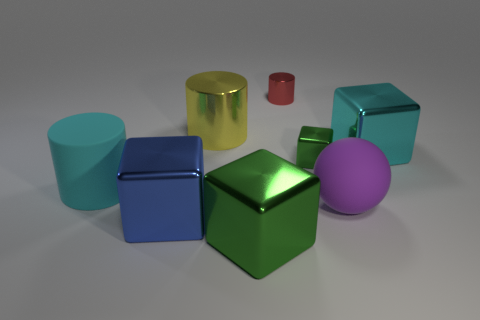What is the size of the metallic cube that is the same color as the rubber cylinder?
Your answer should be very brief. Large. What number of spheres are the same size as the red cylinder?
Your response must be concise. 0. Is the number of tiny objects that are in front of the large blue metal object the same as the number of large cyan metallic blocks?
Your answer should be compact. No. How many large metal cubes are both right of the big purple object and left of the big yellow thing?
Provide a succinct answer. 0. There is a yellow object that is the same material as the cyan block; what is its size?
Keep it short and to the point. Large. How many green things have the same shape as the yellow metallic object?
Give a very brief answer. 0. Is the number of cyan objects that are to the right of the cyan rubber cylinder greater than the number of big rubber cylinders?
Your answer should be very brief. No. There is a large object that is both on the left side of the tiny red cylinder and behind the rubber cylinder; what shape is it?
Your response must be concise. Cylinder. Do the red metal cylinder and the blue metal cube have the same size?
Keep it short and to the point. No. How many blue blocks are behind the large metal cylinder?
Ensure brevity in your answer.  0. 